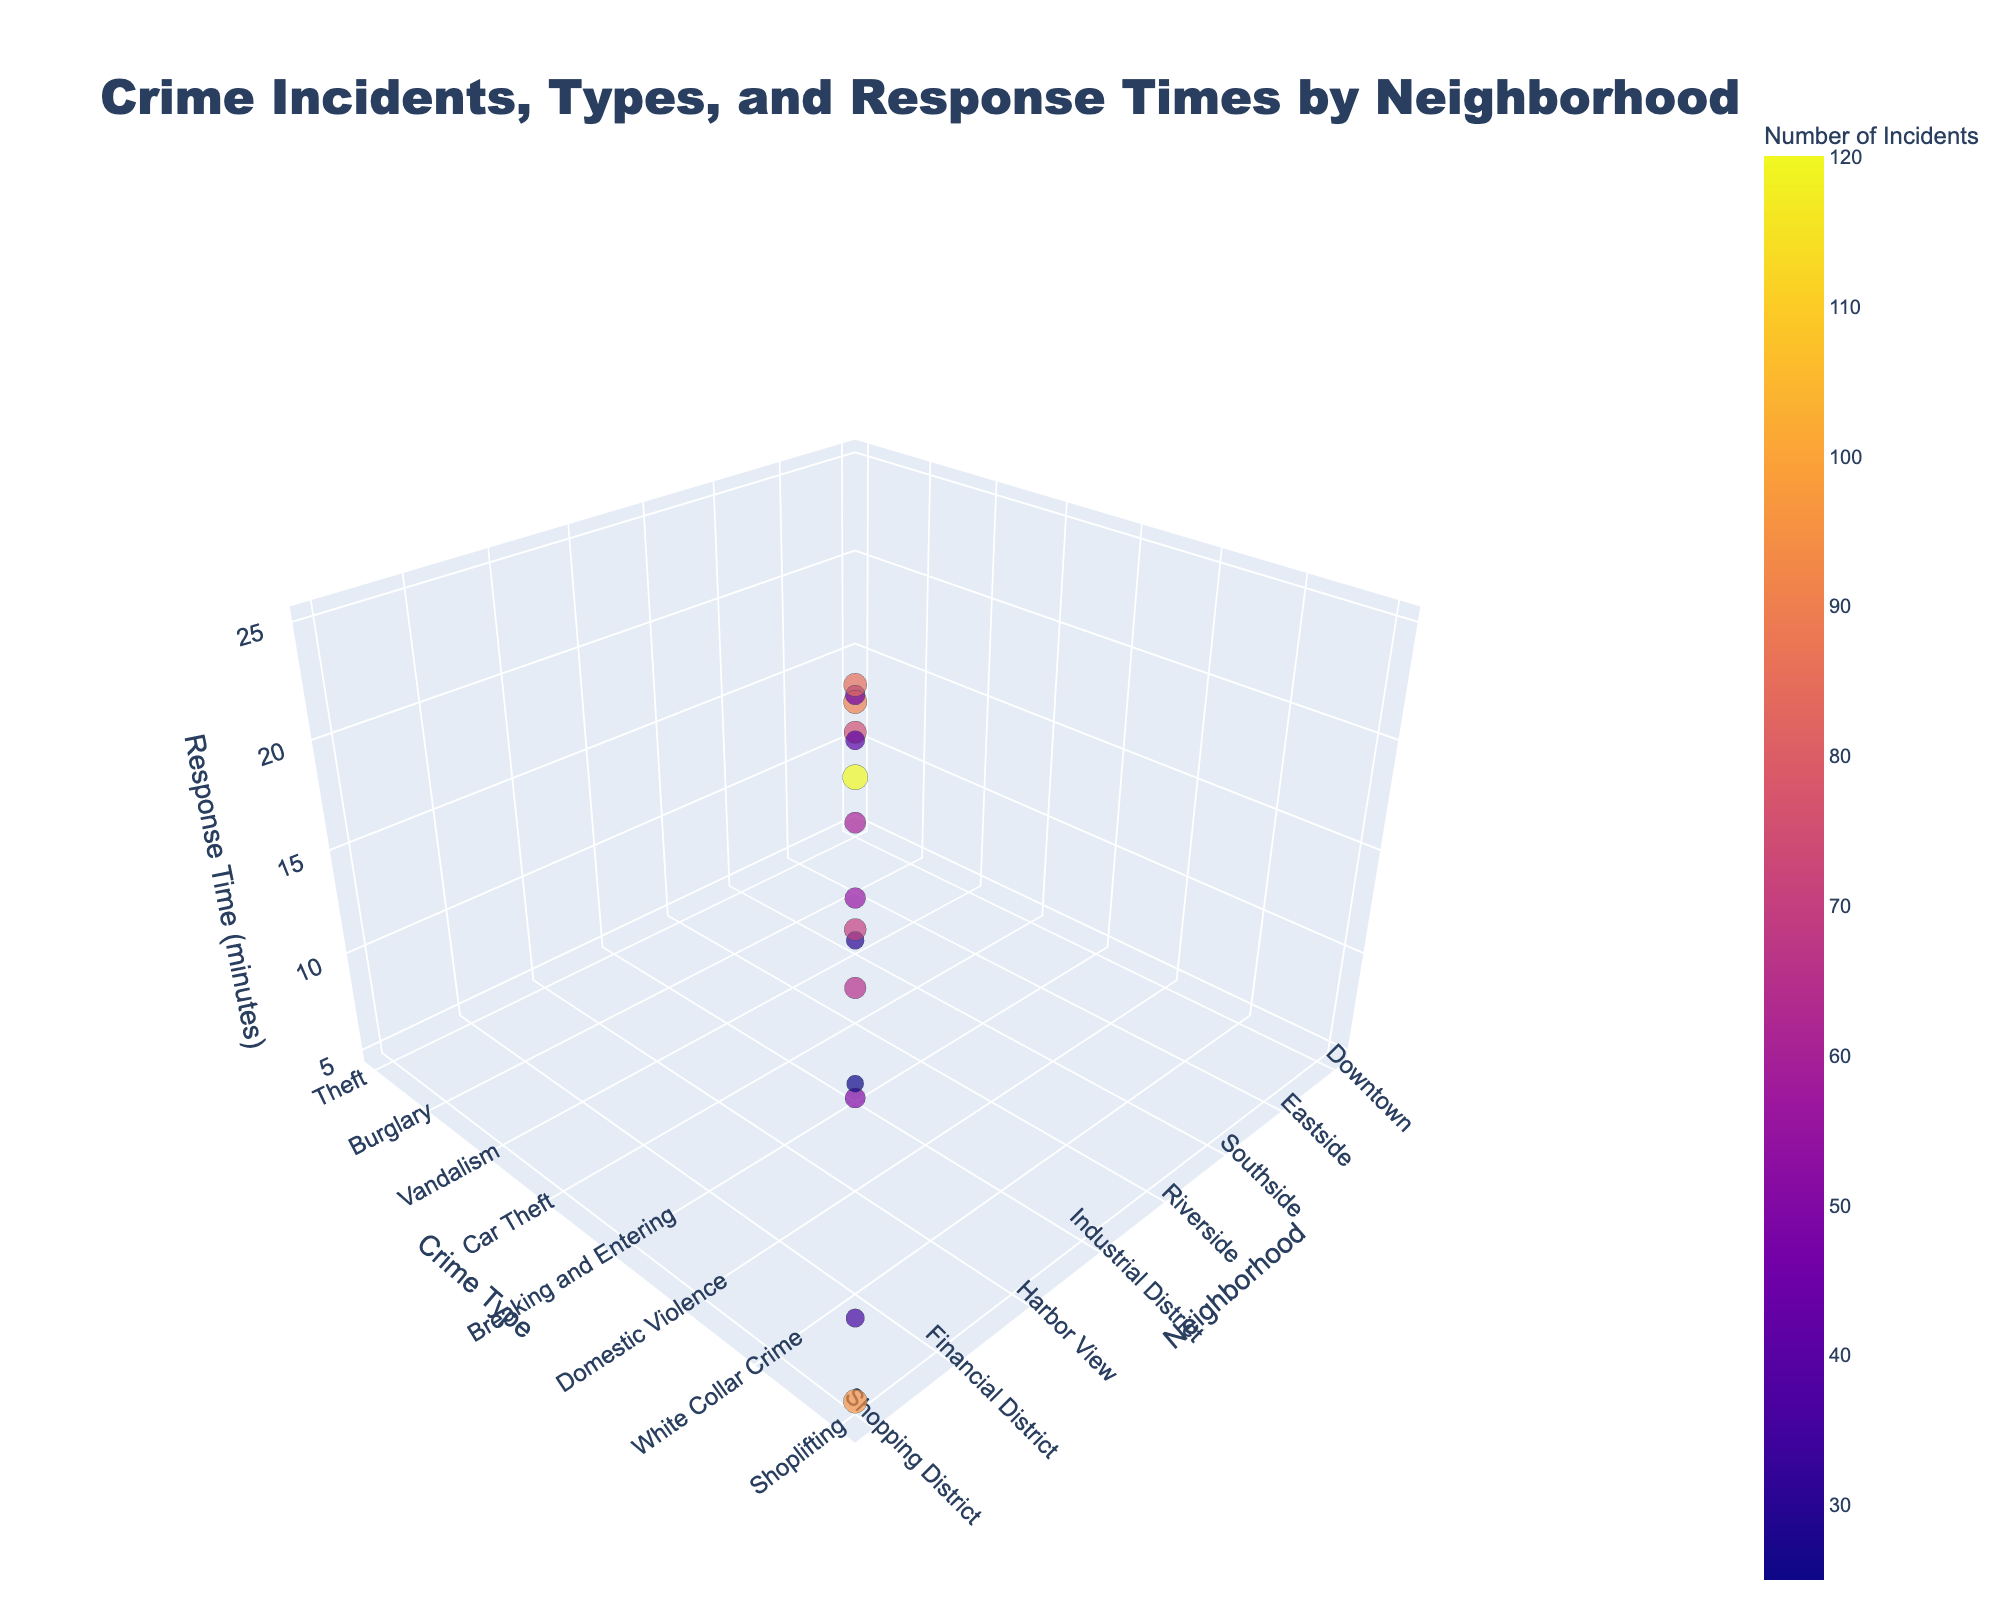What's the title of the figure? The title is prominently displayed at the top of the figure.
Answer: "Crime Incidents, Types, and Response Times by Neighborhood" How are neighborhoods represented in the chart? Neighborhoods are represented along the x-axis, with each bubble corresponding to a different neighborhood.
Answer: Along the x-axis Which neighborhood has the fastest police response time? By examining the z-axis for the smallest value, the lowest response time belongs to the 'Shopping District' shown by the shortest bubble height.
Answer: Shopping District Which type of crime has the highest number of incidents? The bubble representing 'Theft' in Downtown is larger compared to others, indicating the highest number of incidents.
Answer: Theft What is the average response time across all neighborhoods? Sum all response times and divide by the number of neighborhoods: (8 + 12 + 15 + 10 + 18 + 7 + 11 + 20 + 13 + 25 + 9 + 16 + 14 + 6 + 5) / 15 = 13.3 minutes.
Answer: 13.3 minutes Which neighborhood has the least number of incidents, and what are they? By locating the smallest bubble, the 'Financial District' shows the least incidents at 25.
Answer: Financial District, 25 incidents Compare the response time of neighborhoods with high crime rates to those with low crime rates. Higher incident neighborhoods like Downtown (Theft) and Shopping District (Shoplifting) have lower response times (8 and 5 minutes respectively) than lower incident neighborhoods like Financial District (White Collar Crime) with 14 minutes.
Answer: Generally, higher crime rate neighborhoods have quicker response times What is the total number of incidents across all neighborhoods? Sum up all the incidents: 120 + 75 + 90 + 60 + 45 + 30 + 55 + 40 + 70 + 85 + 50 + 65 + 25 + 35 + 95 = 940 incidents.
Answer: 940 incidents Which neighborhood has the highest response time for a specific crime type, and what is the crime type? 'University Area' with 'Noise Complaints' has the highest response time at 25 minutes, indicated by the tallest bubble.
Answer: University Area, Noise Complaints What is the average number of incidents for crimes with a response time higher than 10 minutes? Identify and sum incidents for Response Times > 10: (75 + 90 + 40 + 70 + 85 + 65 + 25), then calculate the average: (75 + 90 + 40 + 70 + 85 + 65 + 25) / 7 = 64.3 incidents.
Answer: 64.3 incidents 